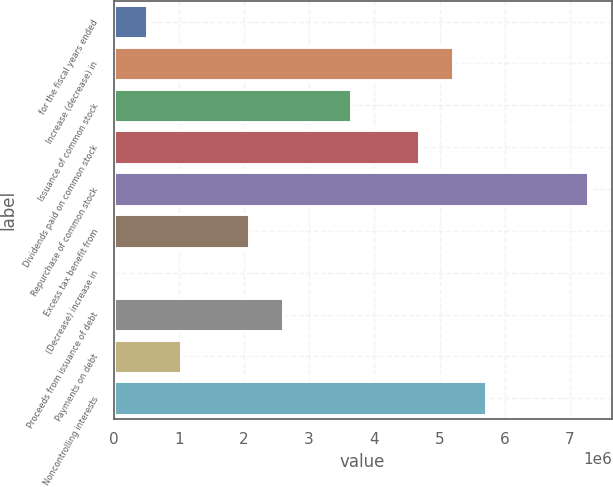Convert chart. <chart><loc_0><loc_0><loc_500><loc_500><bar_chart><fcel>for the fiscal years ended<fcel>Increase (decrease) in<fcel>Issuance of common stock<fcel>Dividends paid on common stock<fcel>Repurchase of common stock<fcel>Excess tax benefit from<fcel>(Decrease) increase in<fcel>Proceeds from issuance of debt<fcel>Payments on debt<fcel>Noncontrolling interests<nl><fcel>519907<fcel>5.19861e+06<fcel>3.63904e+06<fcel>4.67876e+06<fcel>7.27804e+06<fcel>2.07948e+06<fcel>51<fcel>2.59933e+06<fcel>1.03976e+06<fcel>5.71847e+06<nl></chart> 